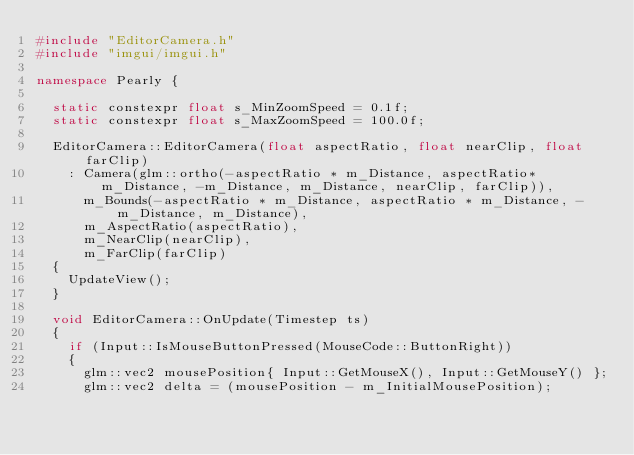<code> <loc_0><loc_0><loc_500><loc_500><_C++_>#include "EditorCamera.h"
#include "imgui/imgui.h"

namespace Pearly {

	static constexpr float s_MinZoomSpeed = 0.1f;
	static constexpr float s_MaxZoomSpeed = 100.0f;

	EditorCamera::EditorCamera(float aspectRatio, float nearClip, float farClip)
		: Camera(glm::ortho(-aspectRatio * m_Distance, aspectRatio* m_Distance, -m_Distance, m_Distance, nearClip, farClip)), 
			m_Bounds(-aspectRatio * m_Distance, aspectRatio * m_Distance, -m_Distance, m_Distance),
			m_AspectRatio(aspectRatio),
			m_NearClip(nearClip),
			m_FarClip(farClip)
	{
		UpdateView();
	}

	void EditorCamera::OnUpdate(Timestep ts)
	{
		if (Input::IsMouseButtonPressed(MouseCode::ButtonRight))
		{
			glm::vec2 mousePosition{ Input::GetMouseX(), Input::GetMouseY() };
			glm::vec2 delta = (mousePosition - m_InitialMousePosition);</code> 